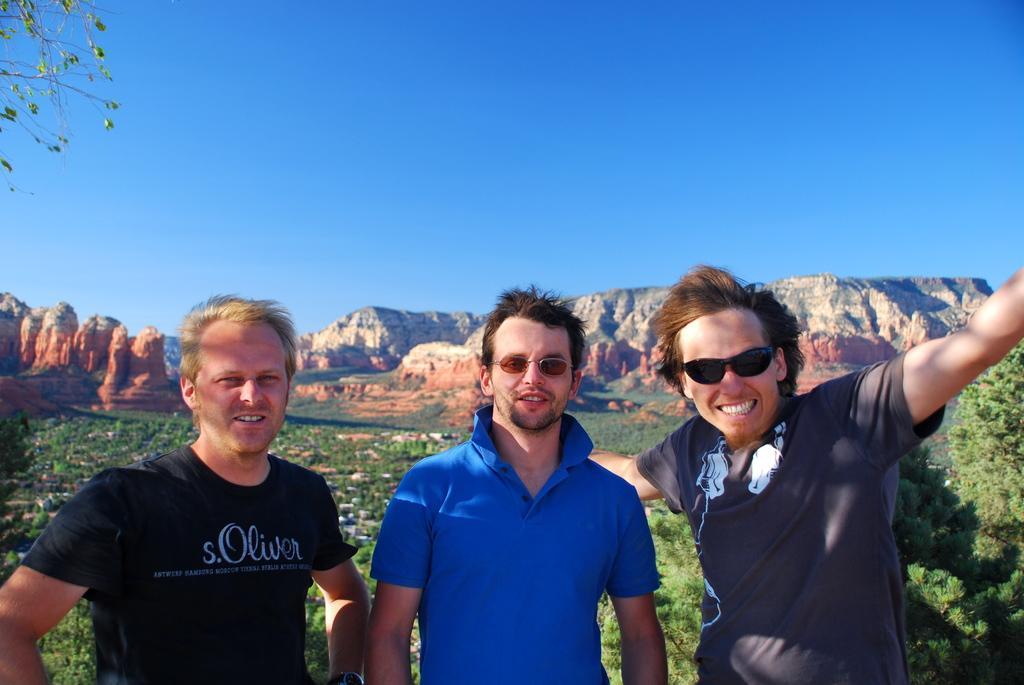In one or two sentences, can you explain what this image depicts? In the center of the image there are people standing. In the background of the image there are mountains. At the top of the image there is sky. There are trees. 